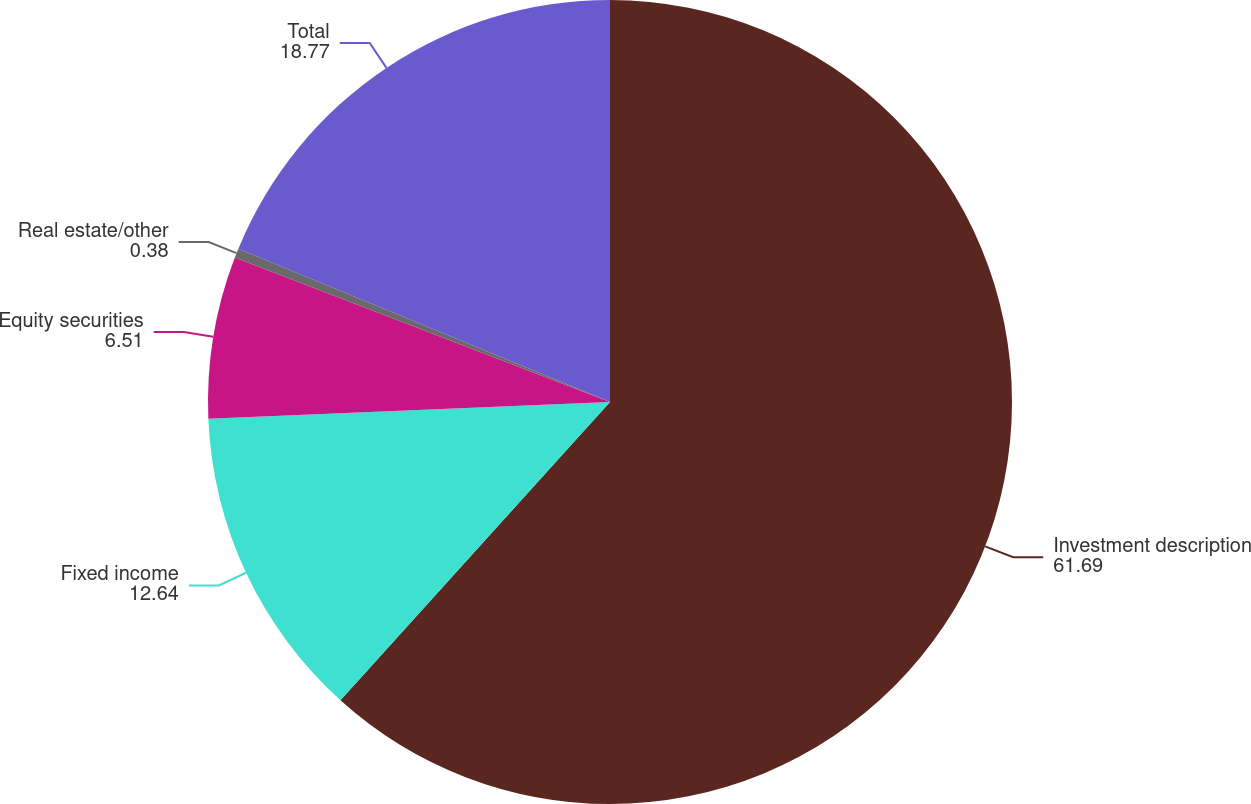Convert chart to OTSL. <chart><loc_0><loc_0><loc_500><loc_500><pie_chart><fcel>Investment description<fcel>Fixed income<fcel>Equity securities<fcel>Real estate/other<fcel>Total<nl><fcel>61.69%<fcel>12.64%<fcel>6.51%<fcel>0.38%<fcel>18.77%<nl></chart> 